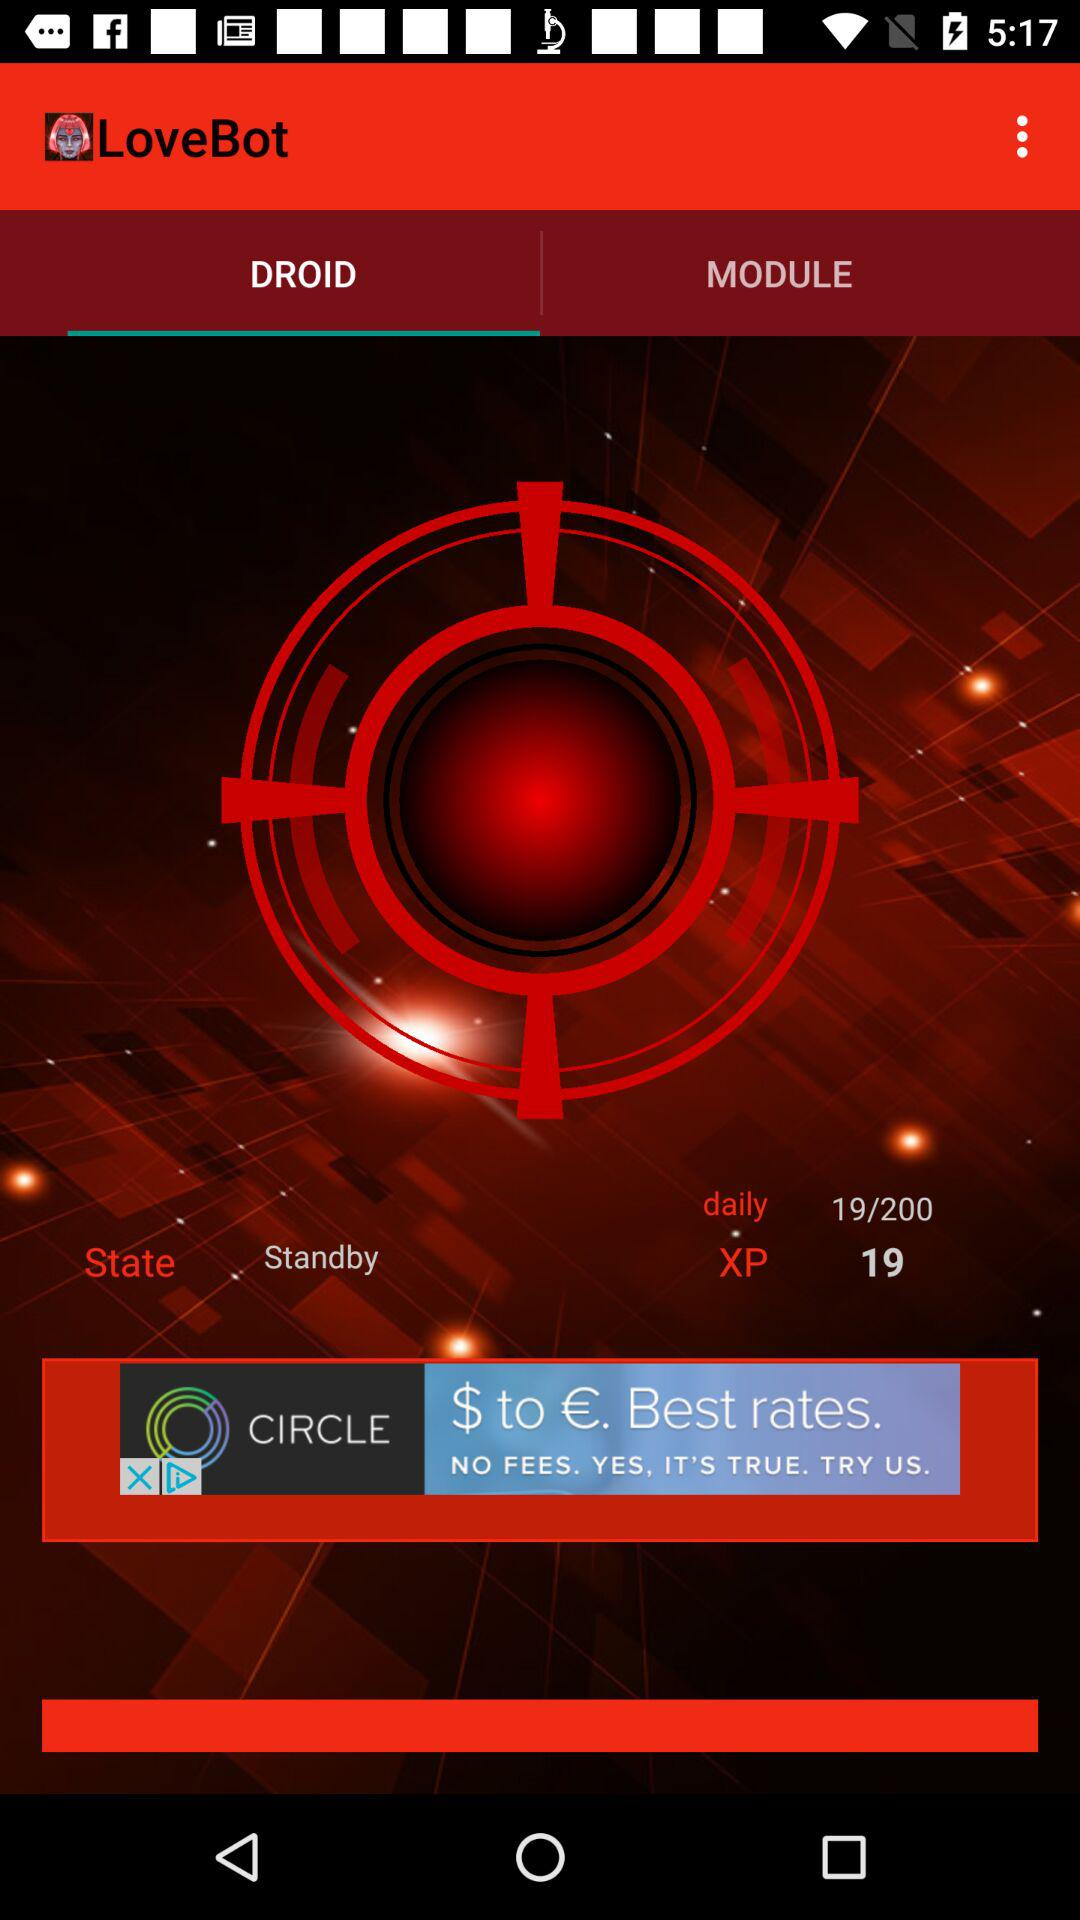What is the daily XP? The daily XP is 19 out of 200. 